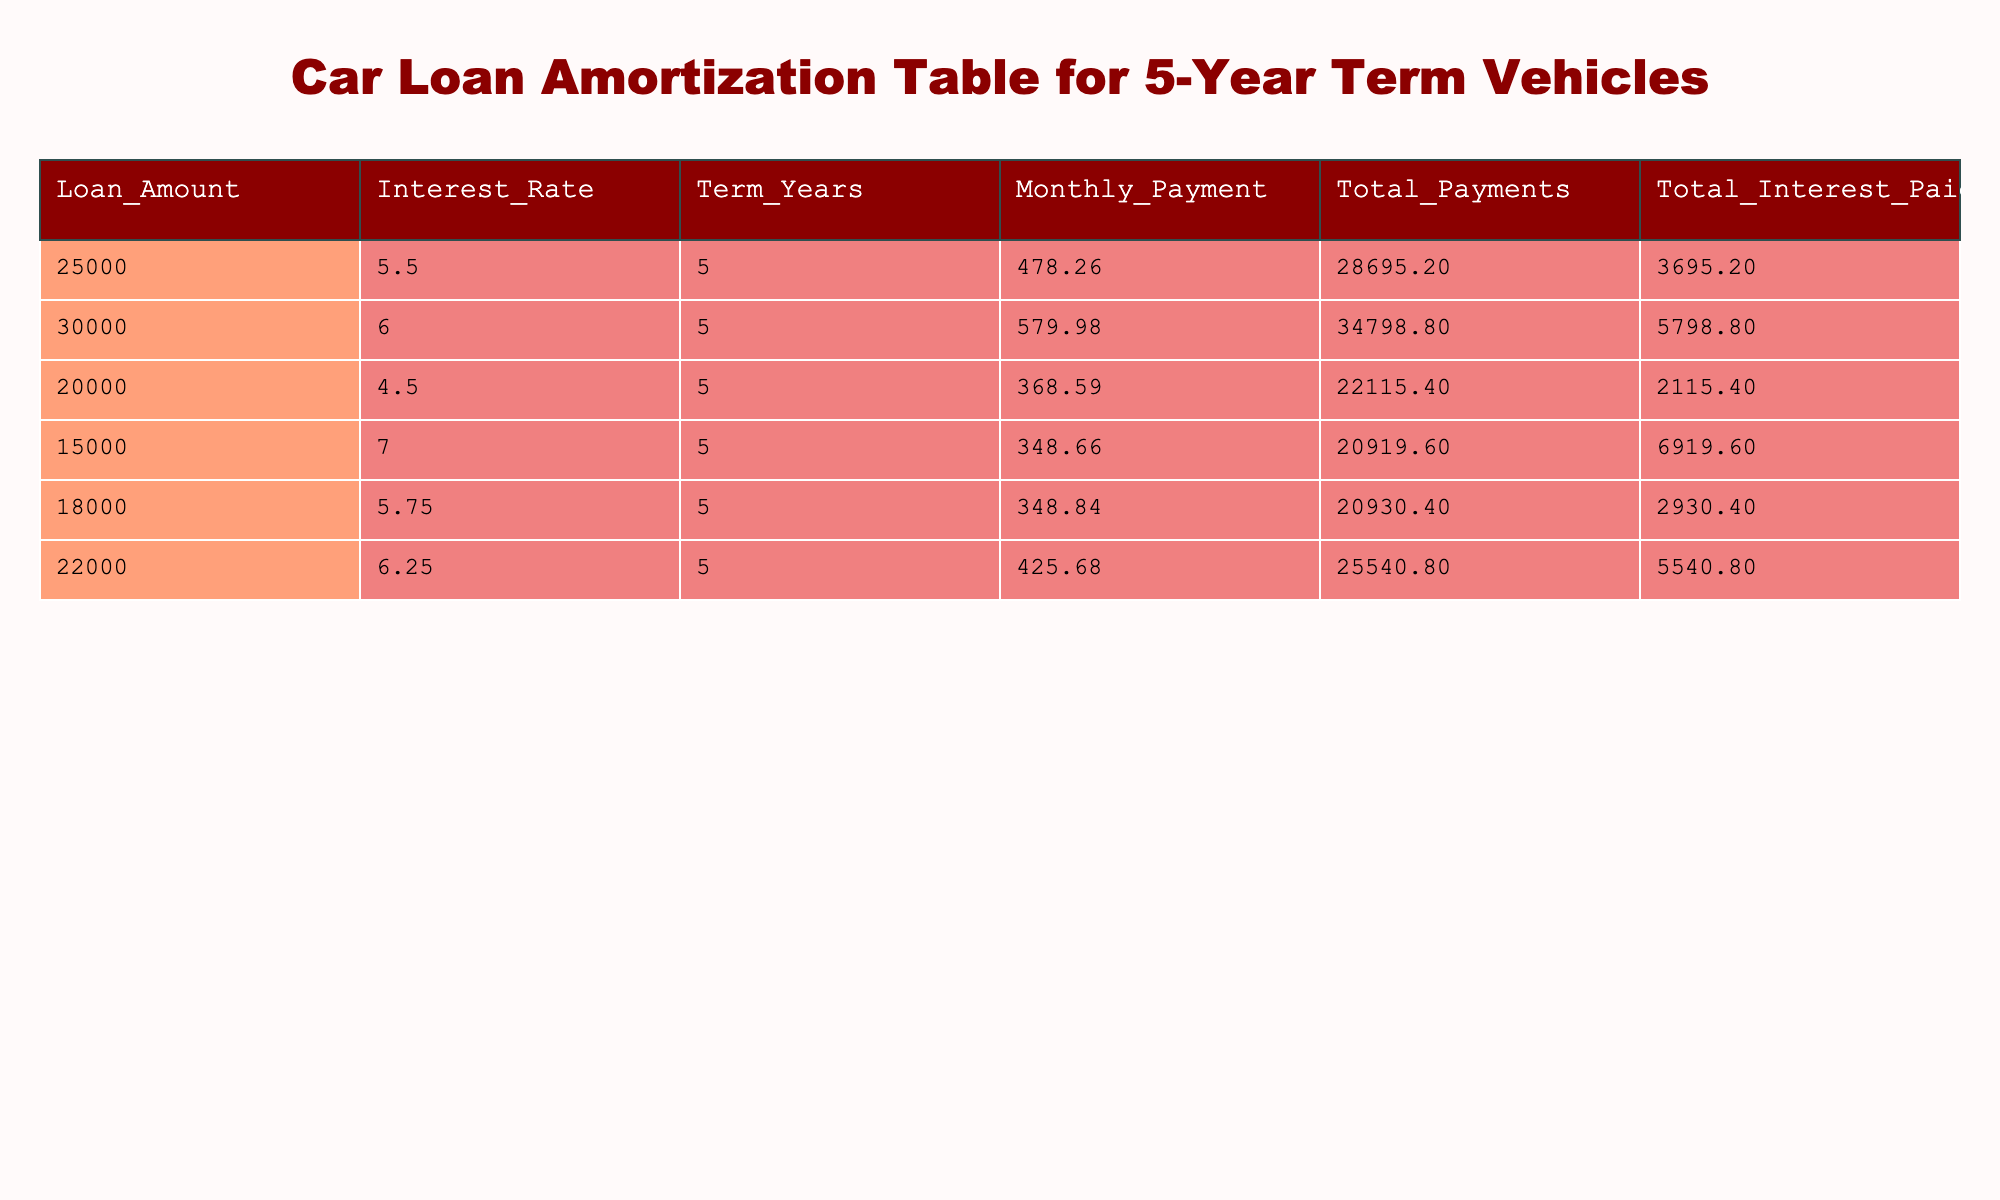What is the loan amount for the highest monthly payment? Looking at the table, the highest monthly payment is 579.98, which corresponds to a loan amount of 30000.
Answer: 30000 What is the total interest paid for the car loan with a loan amount of 20000? The total interest paid for the loan amount of 20000 is directly provided in the table, which shows it is 2115.40.
Answer: 2115.40 Which loan has the lowest interest rate and what is the corresponding monthly payment? The loan with the lowest interest rate is 4.5%, which corresponds to the loan amount of 20000, resulting in a monthly payment of 368.59.
Answer: 368.59 What is the difference in total payments between the highest and lowest loan amounts in this table? The highest loan amount is 30000 with total payments of 34798.80, and the lowest loan amount is 15000, which has total payments of 20919.60. The difference is 34798.80 - 20919.60 = 13879.20.
Answer: 13879.20 Is the total interest paid for a loan amount of 25000 greater than 4000? The total interest paid for the loan amount of 25000 is 3695.20, which is not greater than 4000.
Answer: No Which loan has the lowest total payments and what is that amount? The loan with the lowest total payments is for the amount of 15000, with total payments amounting to 20919.60.
Answer: 20919.60 What is the average monthly payment across all loans listed in the table? The total monthly payments are calculated by adding all the monthly payments (478.26 + 579.98 + 368.59 + 348.66 + 348.84 + 425.68 = 2250.01) and dividing by the number of loans (6). The average is therefore 2250.01 / 6 = 375.00.
Answer: 375.00 Which loan amount results in a total interest paid that is more than 5000? The loan amount of 15000 results in a total interest paid of 6919.60, which is more than 5000.
Answer: 15000 Is there a loan amount for which the total interest paid is less than 3000? Yes, both the loan amounts of 25000 and 20000 have total interest paid amounts of 3695.20 and 2115.40 respectively, where the latter is less than 3000.
Answer: Yes 